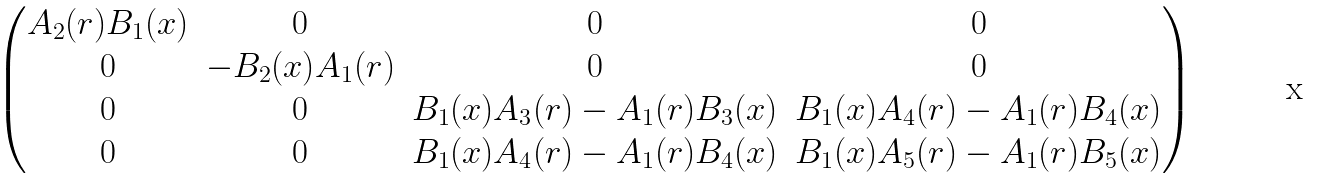Convert formula to latex. <formula><loc_0><loc_0><loc_500><loc_500>\begin{pmatrix} A _ { 2 } ( r ) B _ { 1 } ( x ) & 0 & 0 & 0 \\ 0 & - B _ { 2 } ( x ) A _ { 1 } ( r ) & 0 & 0 \\ 0 & 0 & B _ { 1 } ( x ) A _ { 3 } ( r ) - A _ { 1 } ( r ) B _ { 3 } ( x ) & B _ { 1 } ( x ) A _ { 4 } ( r ) - A _ { 1 } ( r ) B _ { 4 } ( x ) \\ 0 & 0 & B _ { 1 } ( x ) A _ { 4 } ( r ) - A _ { 1 } ( r ) B _ { 4 } ( x ) & B _ { 1 } ( x ) A _ { 5 } ( r ) - A _ { 1 } ( r ) B _ { 5 } ( x ) \end{pmatrix}</formula> 